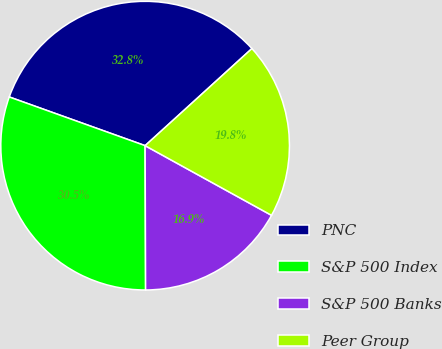Convert chart. <chart><loc_0><loc_0><loc_500><loc_500><pie_chart><fcel>PNC<fcel>S&P 500 Index<fcel>S&P 500 Banks<fcel>Peer Group<nl><fcel>32.78%<fcel>30.53%<fcel>16.93%<fcel>19.76%<nl></chart> 